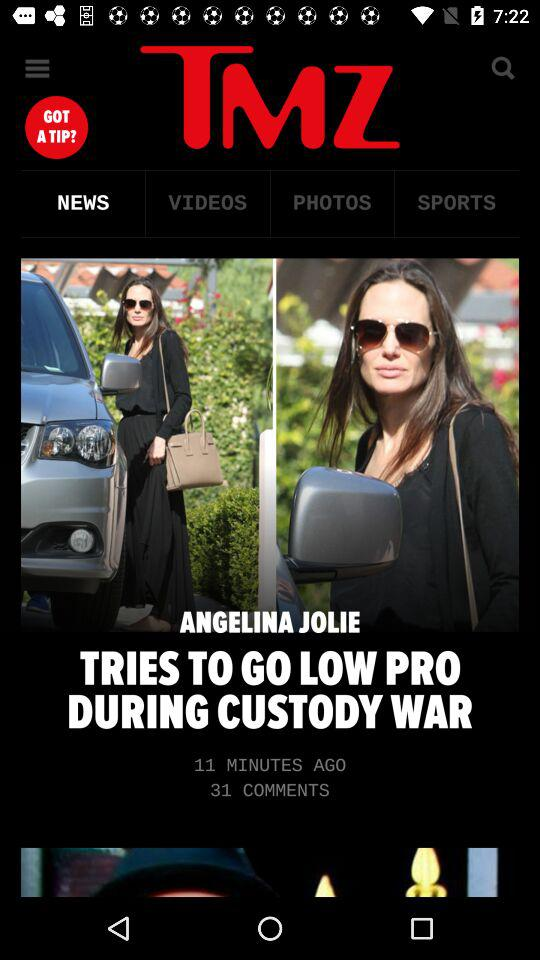How many more comments are there than minutes ago?
Answer the question using a single word or phrase. 20 